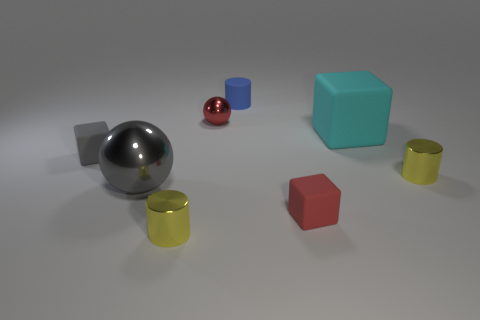Subtract all red balls. How many yellow cylinders are left? 2 Subtract all tiny blue rubber cylinders. How many cylinders are left? 2 Subtract 1 cylinders. How many cylinders are left? 2 Add 1 green matte cubes. How many objects exist? 9 Subtract all blocks. How many objects are left? 5 Subtract all cyan balls. Subtract all cyan blocks. How many balls are left? 2 Subtract 1 gray cubes. How many objects are left? 7 Subtract all gray metallic objects. Subtract all blue metal balls. How many objects are left? 7 Add 8 tiny yellow shiny cylinders. How many tiny yellow shiny cylinders are left? 10 Add 8 gray blocks. How many gray blocks exist? 9 